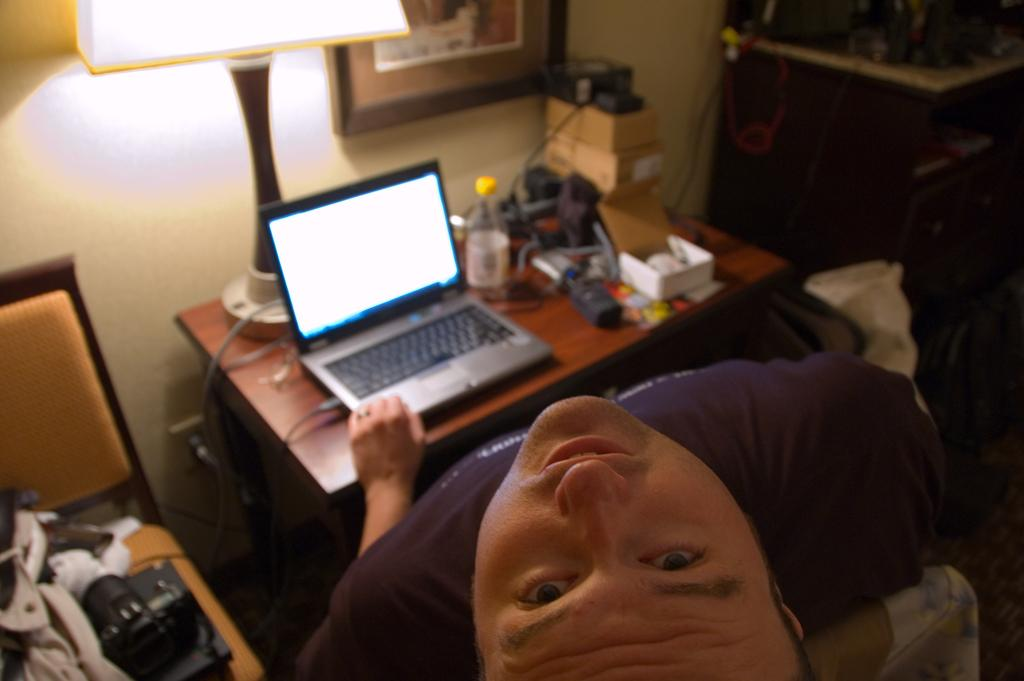What is the person in the image doing? The person is sitting in a chair and working on a laptop. What object is in front of the person? There is a lamp in front of the person. What is the person's posture in the image? The person is tilting their head up. What type of cheese is being used as a pillow in the image? There is no cheese present in the image, and the person is not using any cheese as a pillow. 